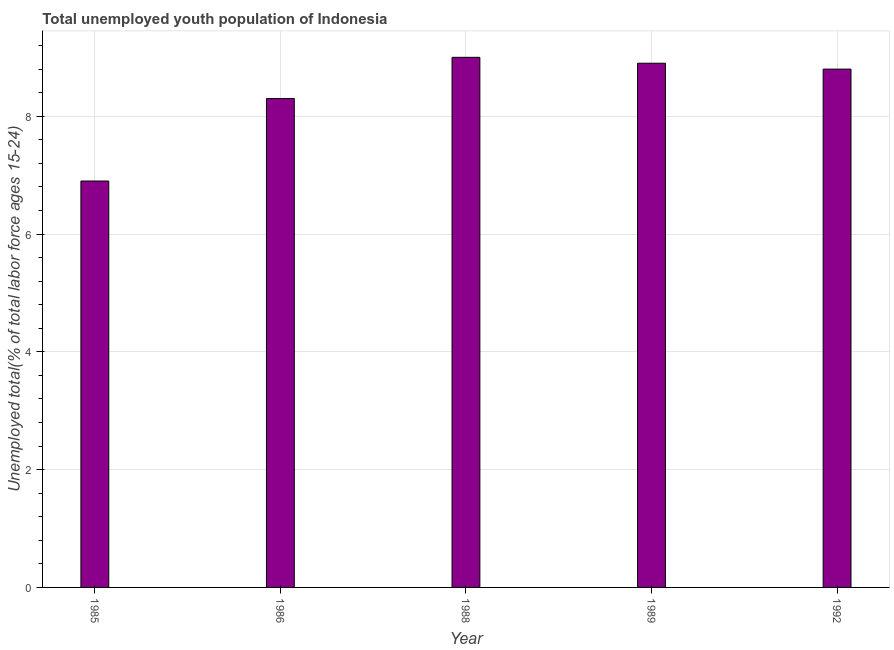Does the graph contain any zero values?
Provide a succinct answer. No. What is the title of the graph?
Make the answer very short. Total unemployed youth population of Indonesia. What is the label or title of the X-axis?
Make the answer very short. Year. What is the label or title of the Y-axis?
Your answer should be very brief. Unemployed total(% of total labor force ages 15-24). Across all years, what is the minimum unemployed youth?
Your response must be concise. 6.9. What is the sum of the unemployed youth?
Keep it short and to the point. 41.9. What is the average unemployed youth per year?
Ensure brevity in your answer.  8.38. What is the median unemployed youth?
Ensure brevity in your answer.  8.8. In how many years, is the unemployed youth greater than 6.8 %?
Provide a succinct answer. 5. Do a majority of the years between 1986 and 1989 (inclusive) have unemployed youth greater than 3.6 %?
Keep it short and to the point. Yes. What is the difference between the highest and the second highest unemployed youth?
Offer a very short reply. 0.1. Is the sum of the unemployed youth in 1988 and 1989 greater than the maximum unemployed youth across all years?
Provide a succinct answer. Yes. How many bars are there?
Provide a short and direct response. 5. What is the difference between two consecutive major ticks on the Y-axis?
Provide a short and direct response. 2. What is the Unemployed total(% of total labor force ages 15-24) in 1985?
Keep it short and to the point. 6.9. What is the Unemployed total(% of total labor force ages 15-24) in 1986?
Keep it short and to the point. 8.3. What is the Unemployed total(% of total labor force ages 15-24) in 1989?
Offer a terse response. 8.9. What is the Unemployed total(% of total labor force ages 15-24) in 1992?
Keep it short and to the point. 8.8. What is the difference between the Unemployed total(% of total labor force ages 15-24) in 1985 and 1986?
Your response must be concise. -1.4. What is the difference between the Unemployed total(% of total labor force ages 15-24) in 1985 and 1988?
Provide a succinct answer. -2.1. What is the difference between the Unemployed total(% of total labor force ages 15-24) in 1985 and 1989?
Offer a terse response. -2. What is the difference between the Unemployed total(% of total labor force ages 15-24) in 1986 and 1989?
Your answer should be compact. -0.6. What is the difference between the Unemployed total(% of total labor force ages 15-24) in 1988 and 1992?
Your response must be concise. 0.2. What is the difference between the Unemployed total(% of total labor force ages 15-24) in 1989 and 1992?
Your answer should be compact. 0.1. What is the ratio of the Unemployed total(% of total labor force ages 15-24) in 1985 to that in 1986?
Keep it short and to the point. 0.83. What is the ratio of the Unemployed total(% of total labor force ages 15-24) in 1985 to that in 1988?
Your response must be concise. 0.77. What is the ratio of the Unemployed total(% of total labor force ages 15-24) in 1985 to that in 1989?
Ensure brevity in your answer.  0.78. What is the ratio of the Unemployed total(% of total labor force ages 15-24) in 1985 to that in 1992?
Provide a succinct answer. 0.78. What is the ratio of the Unemployed total(% of total labor force ages 15-24) in 1986 to that in 1988?
Your answer should be very brief. 0.92. What is the ratio of the Unemployed total(% of total labor force ages 15-24) in 1986 to that in 1989?
Provide a short and direct response. 0.93. What is the ratio of the Unemployed total(% of total labor force ages 15-24) in 1986 to that in 1992?
Ensure brevity in your answer.  0.94. What is the ratio of the Unemployed total(% of total labor force ages 15-24) in 1988 to that in 1989?
Ensure brevity in your answer.  1.01. 